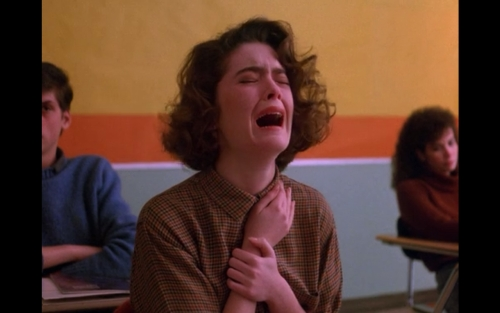Describe the emotional atmosphere conveyed by the character's expression in the image. The character in the image seems to be experiencing a strong emotion, possibly distress or grief. Her expression, with eyes closed tightly and a hand to her throat, suggests she's going through a moment of intense feeling, which could be related to the context of the scene she is in. 